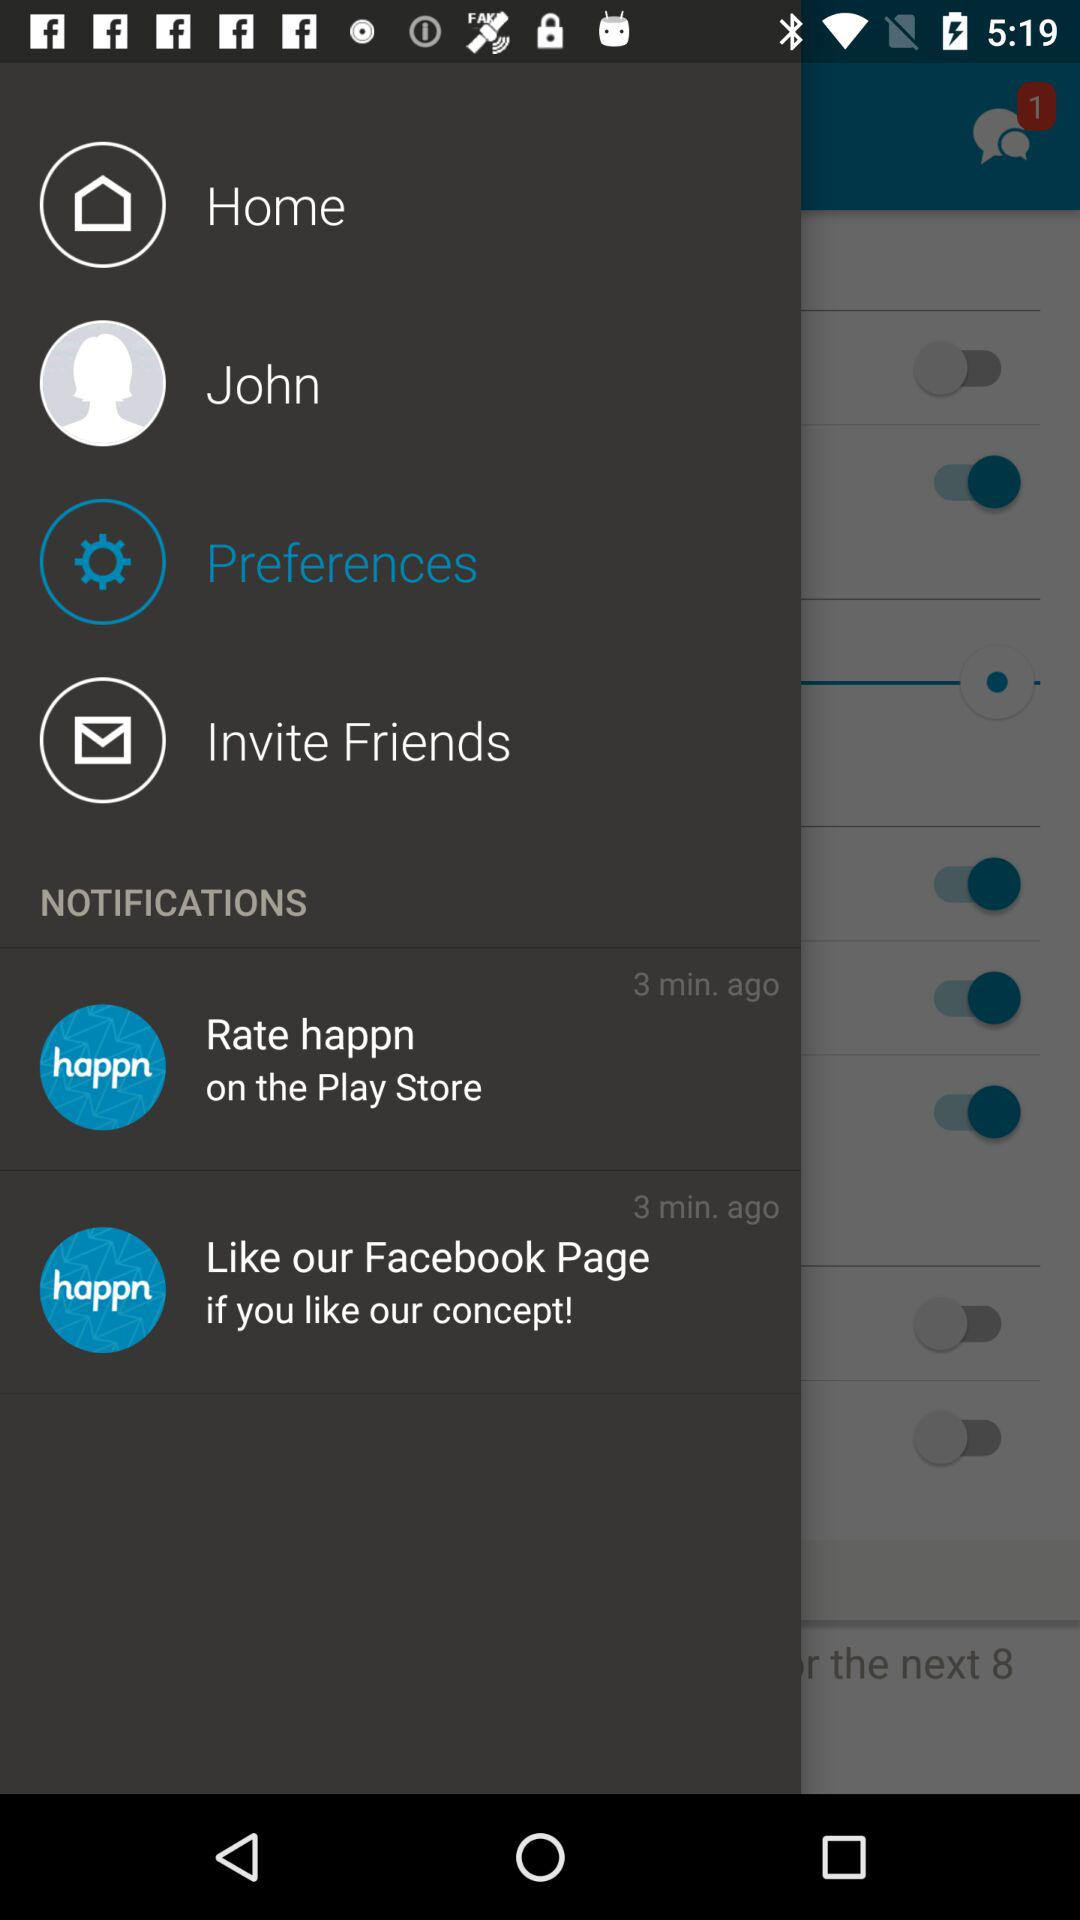I'd like to know where I can like this app?
When the provided information is insufficient, respond with <no answer>. <no answer> 